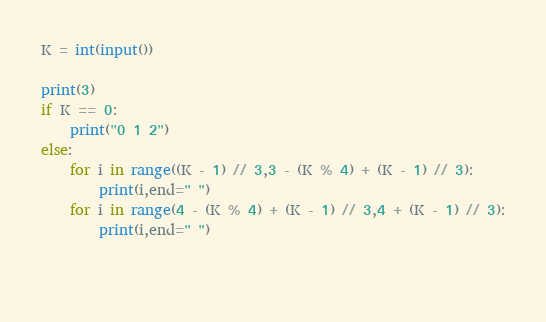Convert code to text. <code><loc_0><loc_0><loc_500><loc_500><_Python_>K = int(input())

print(3)
if K == 0:
    print("0 1 2")
else:
    for i in range((K - 1) // 3,3 - (K % 4) + (K - 1) // 3):
        print(i,end=" ")
    for i in range(4 - (K % 4) + (K - 1) // 3,4 + (K - 1) // 3):
        print(i,end=" ")

    
</code> 